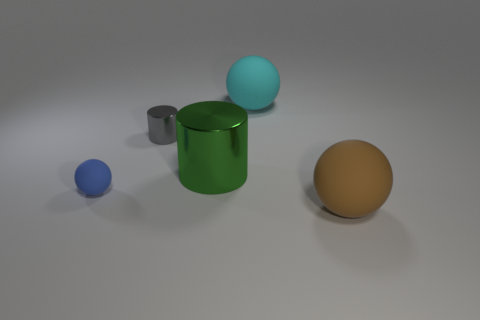Subtract all big matte spheres. How many spheres are left? 1 Subtract all cyan spheres. How many spheres are left? 2 Add 2 large metallic objects. How many objects exist? 7 Subtract all spheres. How many objects are left? 2 Subtract all brown blocks. How many gray cylinders are left? 1 Add 3 brown shiny balls. How many brown shiny balls exist? 3 Subtract 0 yellow cylinders. How many objects are left? 5 Subtract 1 cylinders. How many cylinders are left? 1 Subtract all brown cylinders. Subtract all purple cubes. How many cylinders are left? 2 Subtract all blue balls. Subtract all metallic things. How many objects are left? 2 